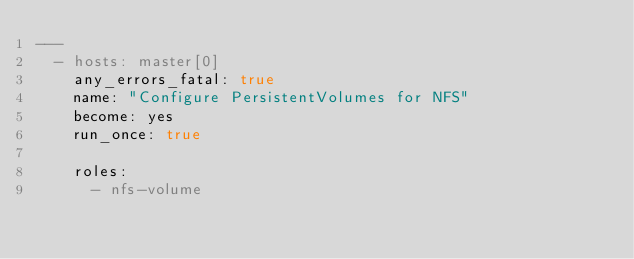Convert code to text. <code><loc_0><loc_0><loc_500><loc_500><_YAML_>---
  - hosts: master[0]
    any_errors_fatal: true
    name: "Configure PersistentVolumes for NFS"
    become: yes
    run_once: true

    roles:
      - nfs-volume
</code> 